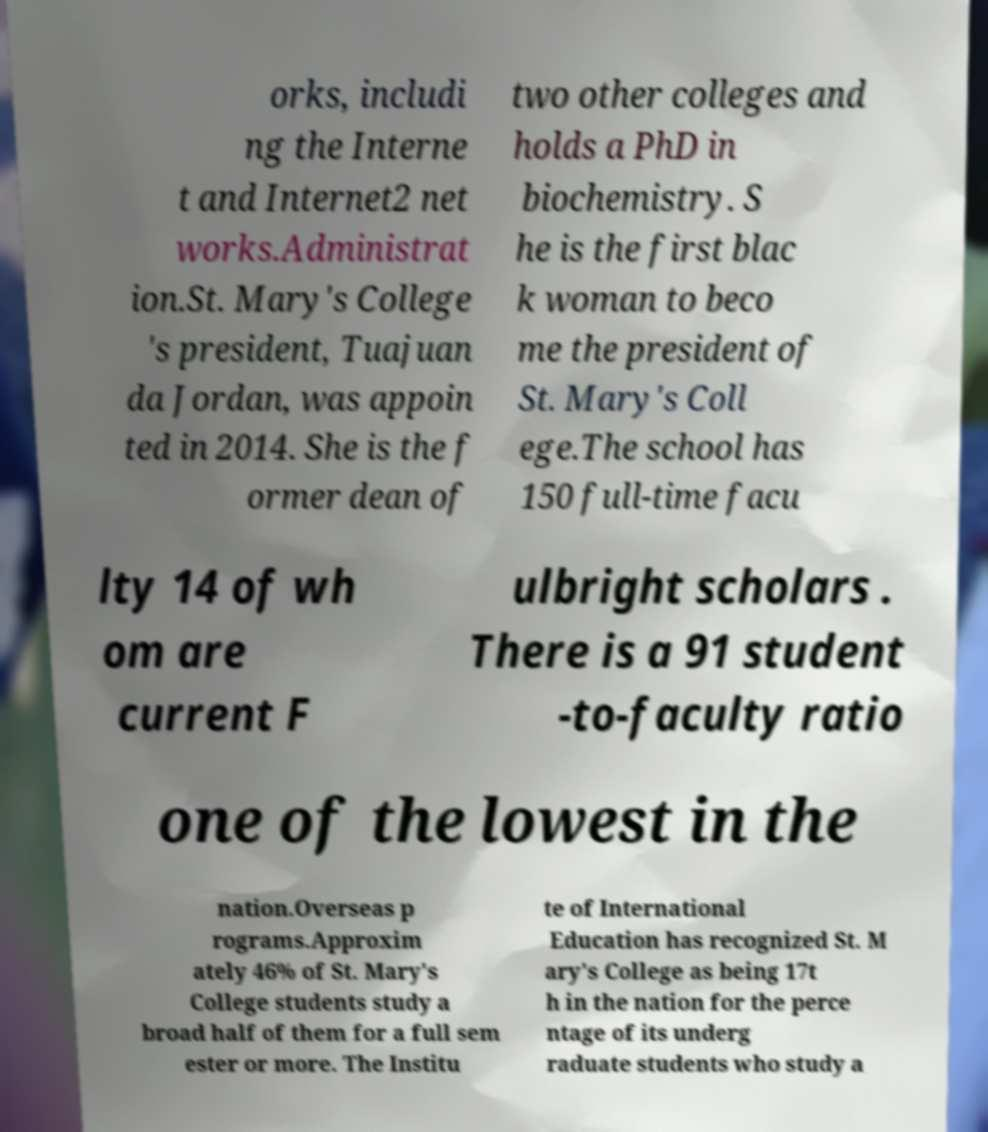Could you extract and type out the text from this image? orks, includi ng the Interne t and Internet2 net works.Administrat ion.St. Mary's College 's president, Tuajuan da Jordan, was appoin ted in 2014. She is the f ormer dean of two other colleges and holds a PhD in biochemistry. S he is the first blac k woman to beco me the president of St. Mary's Coll ege.The school has 150 full-time facu lty 14 of wh om are current F ulbright scholars . There is a 91 student -to-faculty ratio one of the lowest in the nation.Overseas p rograms.Approxim ately 46% of St. Mary's College students study a broad half of them for a full sem ester or more. The Institu te of International Education has recognized St. M ary's College as being 17t h in the nation for the perce ntage of its underg raduate students who study a 